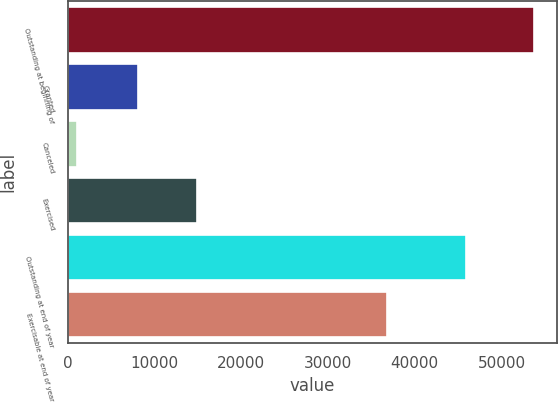Convert chart. <chart><loc_0><loc_0><loc_500><loc_500><bar_chart><fcel>Outstanding at beginning of<fcel>Granted<fcel>Canceled<fcel>Exercised<fcel>Outstanding at end of year<fcel>Exercisable at end of year<nl><fcel>53702<fcel>8145<fcel>1081<fcel>14838<fcel>45928<fcel>36832<nl></chart> 